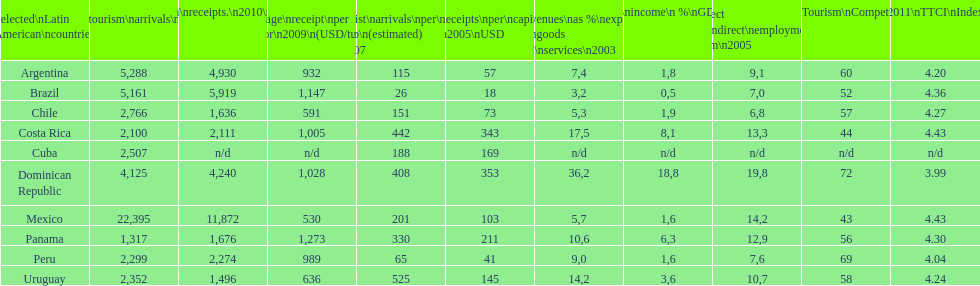How many international tourism arrivals in 2010(x1000) did mexico have? 22,395. 